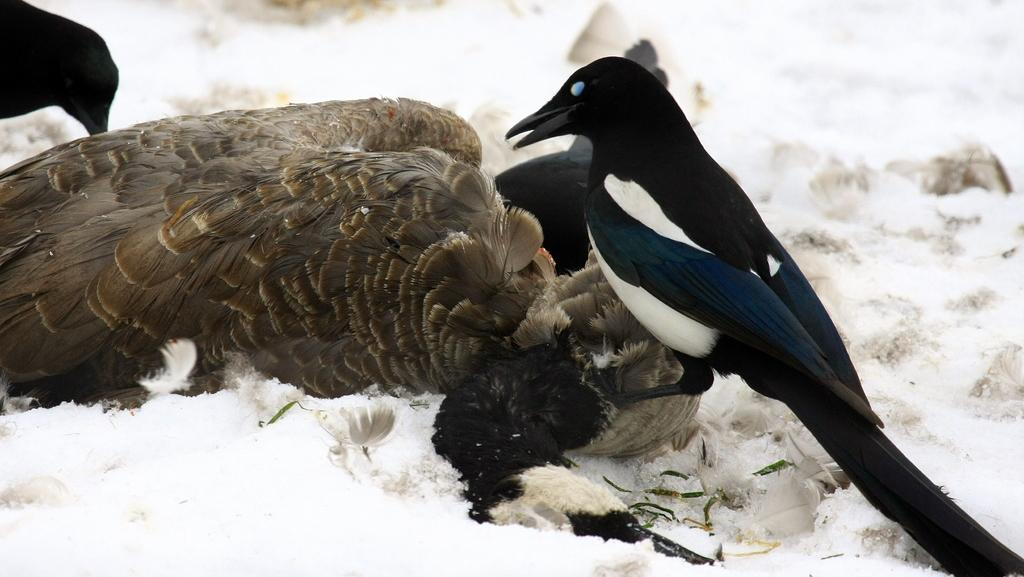What type of animals can be seen in the image? There are birds in the image. What is the surface on which the birds are standing? The birds are on the snow. Can you describe the position of one of the birds? One bird is laying down. What type of hate can be seen on the branch in the image? There is no hate or branch present in the image; it features birds on the snow. 